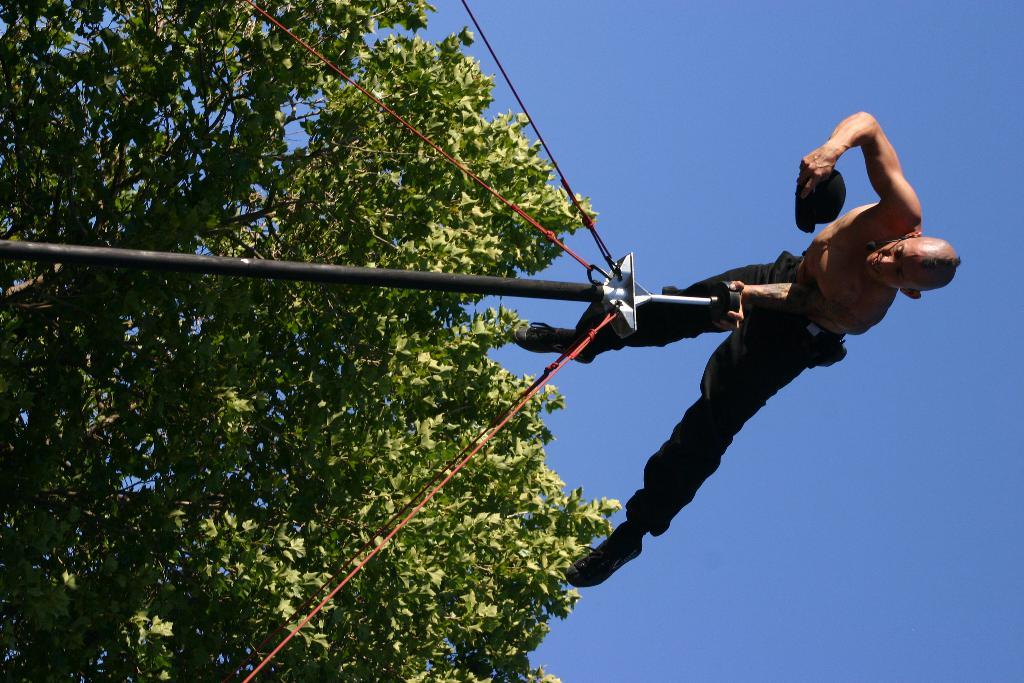What activity is the person in the image performing? The person is doing gymnastics in the image. What equipment is the person using for gymnastics? The person is using a pole for gymnastics. What type of natural environment can be seen in the image? There are trees visible in the image. What other equipment is present in the image? There are ropes in the image. What is visible in the background of the image? The sky is visible in the image. What type of kettle can be seen boiling water in the image? There is no kettle present in the image; it features a person doing gymnastics with a pole. How does the person fall from the pole in the image? The person does not fall from the pole in the image; they are performing gymnastics. 